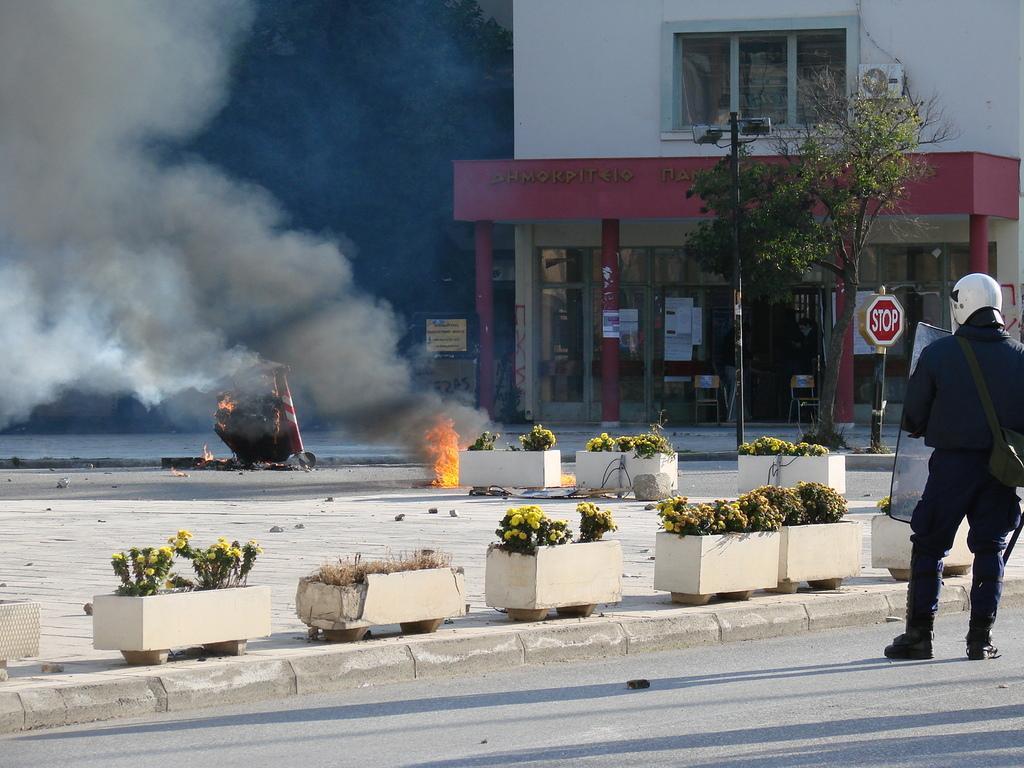How would you summarize this image in a sentence or two? In this picture there is a person standing on the road and wore helmet and carrying a bag and we can see plants with pots, boards, lights, poles, smoke and tree. In the background of the image we can see building, pillars and trees. 